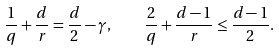Convert formula to latex. <formula><loc_0><loc_0><loc_500><loc_500>\frac { 1 } { q } + \frac { d } { r } = \frac { d } { 2 } - \gamma , \quad \frac { 2 } { q } + \frac { d - 1 } { r } \leq \frac { d - 1 } { 2 } .</formula> 